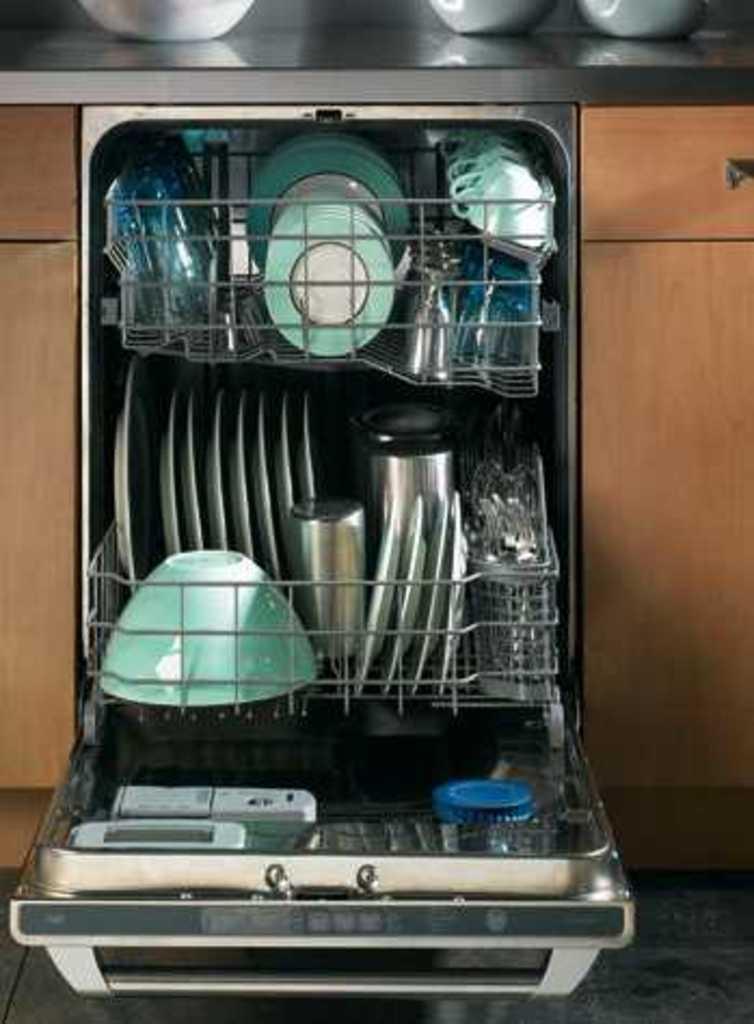Can you describe this image briefly? This image consists of a stand in which there are utensils. On the left and right, there are cupboards. At the top, we can see the bowls on the desk. 